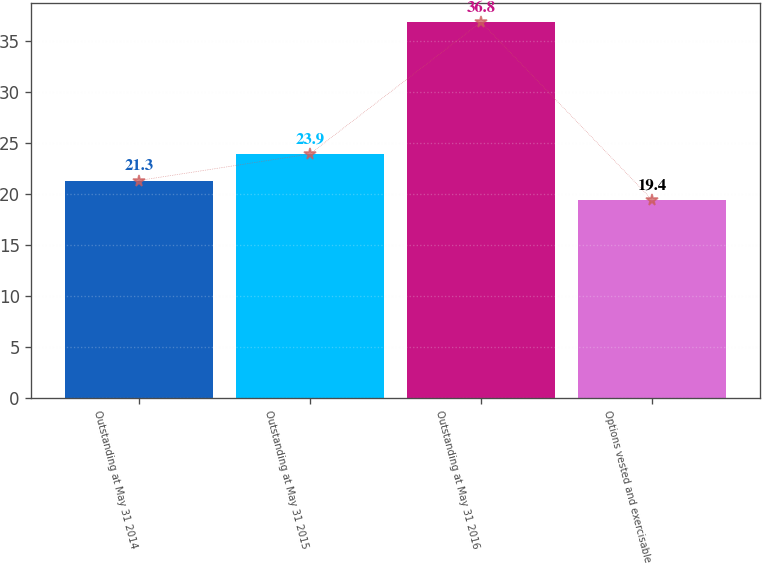Convert chart to OTSL. <chart><loc_0><loc_0><loc_500><loc_500><bar_chart><fcel>Outstanding at May 31 2014<fcel>Outstanding at May 31 2015<fcel>Outstanding at May 31 2016<fcel>Options vested and exercisable<nl><fcel>21.3<fcel>23.9<fcel>36.8<fcel>19.4<nl></chart> 